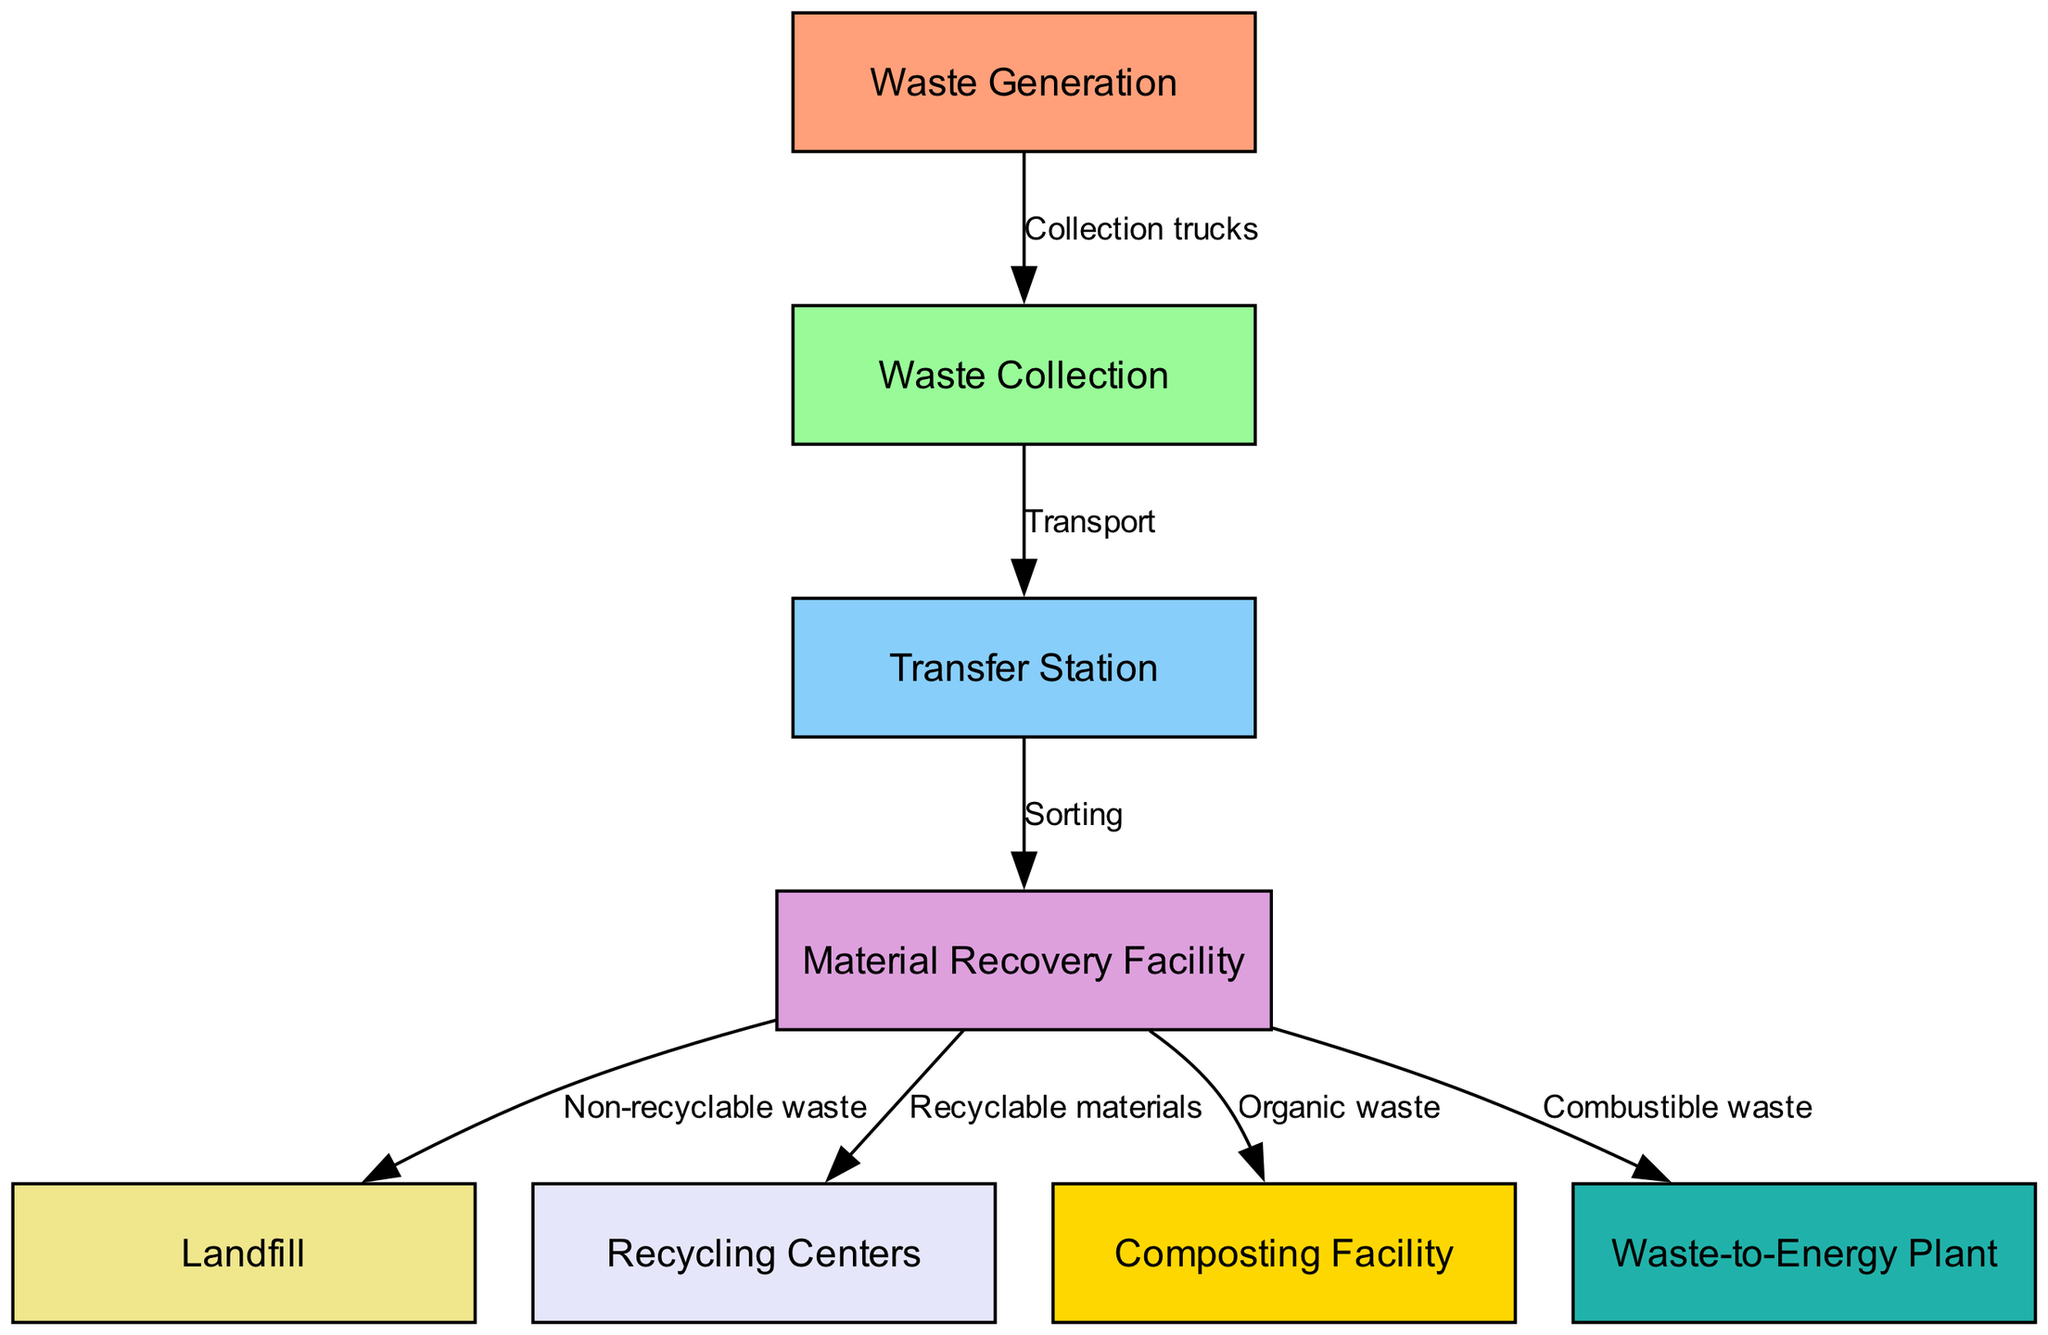What is the first step in the waste management process? The first step according to the diagram is "Waste Generation," which initiates the entire process of urban waste management and recycling.
Answer: Waste Generation How many nodes are there in the diagram? By counting all individual elements represented as nodes in the flowchart, we determine that there are eight nodes in total.
Answer: 8 What type of waste is sent to the Landfill? The process shows that "Non-recyclable waste" is the type of waste that gets directed to the Landfill after sorting.
Answer: Non-recyclable waste What follows the Waste Collection stage? Following the Waste Collection stage in the flowchart, the next step is "Transfer Station," where the collected waste is taken for further processing.
Answer: Transfer Station Which node receives Recyclable materials? The diagram indicates that Recyclable materials are sent from the Material Recovery Facility to the Recycling Centers, making Recycling Centers the recipient.
Answer: Recycling Centers What is the relationship between the Material Recovery Facility and the Composting Facility? The flowchart illustrates that the Material Recovery Facility distributes "Organic waste" specifically to the Composting Facility in the waste management process.
Answer: Organic waste How many edges connect to the Material Recovery Facility? Upon reviewing the connections depicted in the diagram, there are four edges leading to various destinations from the Material Recovery Facility.
Answer: 4 What type of facility processes Combustible waste? The diagram specifies that "Combustible waste" is processed at the Waste-to-Energy Plant, which is the designated facility for this type of waste.
Answer: Waste-to-Energy Plant What action occurs between Transfer Station and Material Recovery Facility? Between the Transfer Station and Material Recovery Facility, the action described is "Sorting," which denotes the process of separating the waste before further management.
Answer: Sorting 